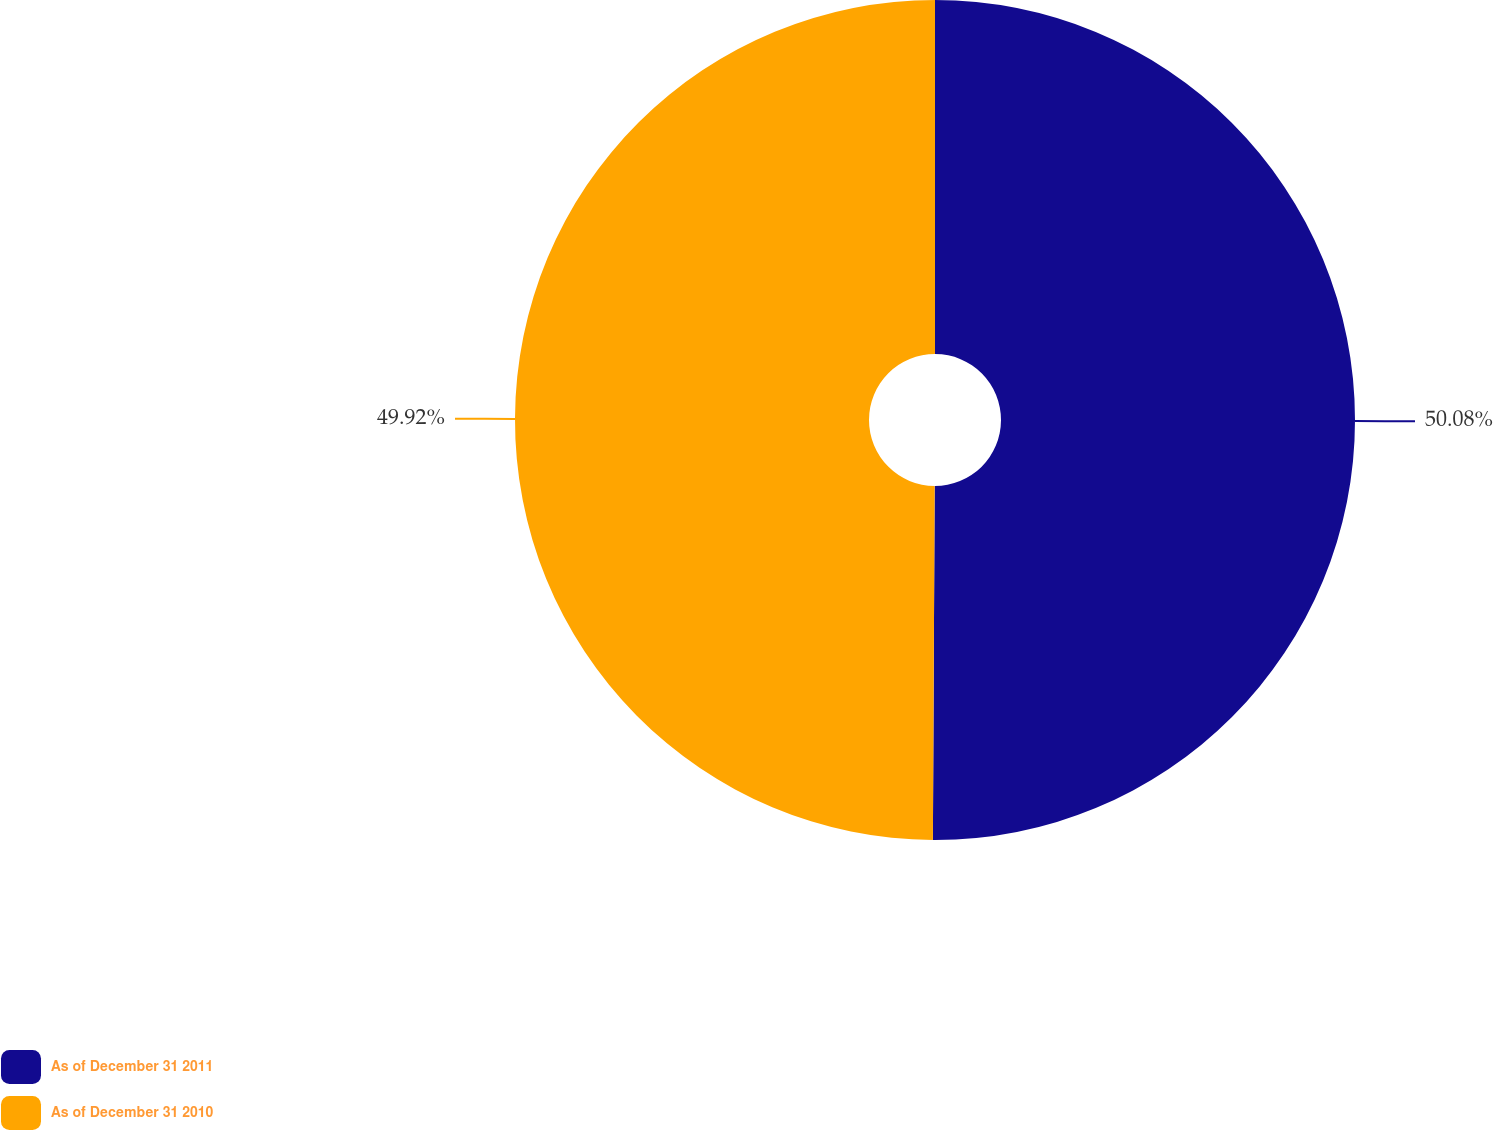<chart> <loc_0><loc_0><loc_500><loc_500><pie_chart><fcel>As of December 31 2011<fcel>As of December 31 2010<nl><fcel>50.08%<fcel>49.92%<nl></chart> 